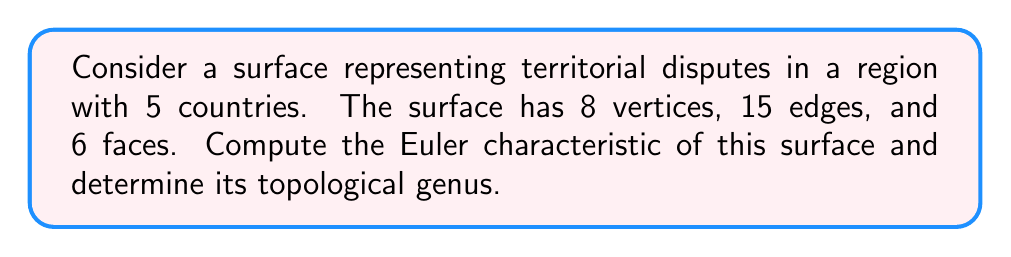Could you help me with this problem? To solve this problem, we'll follow these steps:

1. Calculate the Euler characteristic using the given information.
2. Use the Euler characteristic to determine the genus of the surface.

Step 1: Calculating the Euler characteristic

The Euler characteristic $\chi$ of a surface is defined as:

$$\chi = V - E + F$$

Where:
$V$ = number of vertices
$E$ = number of edges
$F$ = number of faces

Given:
$V = 8$
$E = 15$
$F = 6$

Let's substitute these values into the formula:

$$\chi = 8 - 15 + 6 = -1$$

Step 2: Determining the genus

For a closed orientable surface, the Euler characteristic is related to the genus $g$ by the formula:

$$\chi = 2 - 2g$$

We can rearrange this to solve for $g$:

$$g = \frac{2 - \chi}{2}$$

Substituting our calculated value of $\chi = -1$:

$$g = \frac{2 - (-1)}{2} = \frac{3}{2} = 1.5$$

Since the genus must be a non-negative integer, we round up to the nearest whole number:

$$g = 2$$

This means the surface is topologically equivalent to a double torus (a surface with two holes).
Answer: The Euler characteristic of the surface is $\chi = -1$, and its topological genus is $g = 2$. 